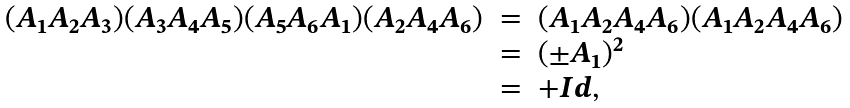Convert formula to latex. <formula><loc_0><loc_0><loc_500><loc_500>\begin{array} { l l l } ( A _ { 1 } A _ { 2 } A _ { 3 } ) ( A _ { 3 } A _ { 4 } A _ { 5 } ) ( A _ { 5 } A _ { 6 } A _ { 1 } ) ( A _ { 2 } A _ { 4 } A _ { 6 } ) & = & ( A _ { 1 } A _ { 2 } A _ { 4 } A _ { 6 } ) ( A _ { 1 } A _ { 2 } A _ { 4 } A _ { 6 } ) \\ & = & ( \pm A _ { 1 } ) ^ { 2 } \\ & = & + { I d } , \end{array}</formula> 